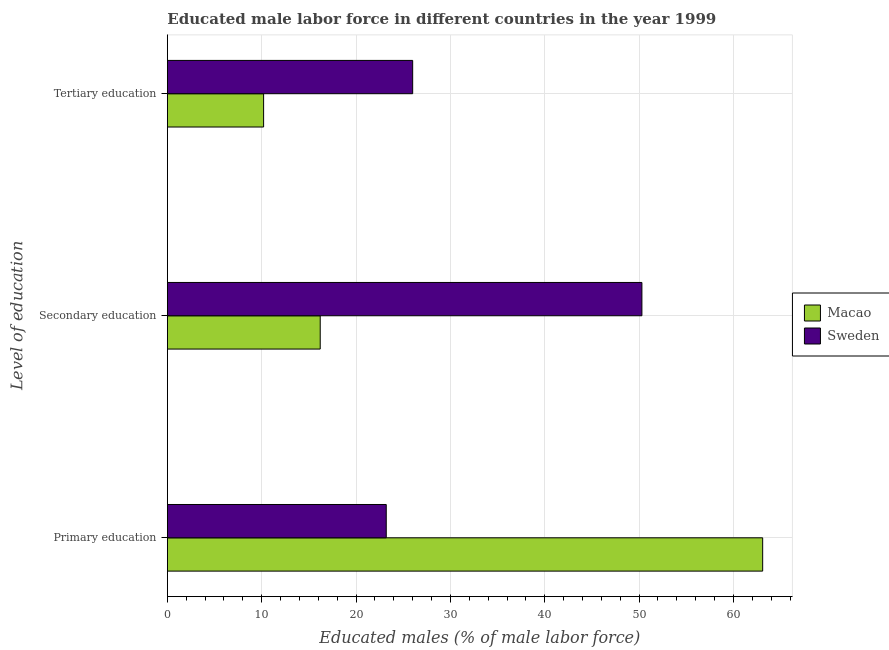How many different coloured bars are there?
Your answer should be compact. 2. Are the number of bars per tick equal to the number of legend labels?
Make the answer very short. Yes. How many bars are there on the 3rd tick from the top?
Your response must be concise. 2. What is the label of the 2nd group of bars from the top?
Ensure brevity in your answer.  Secondary education. What is the percentage of male labor force who received secondary education in Macao?
Your answer should be compact. 16.2. Across all countries, what is the maximum percentage of male labor force who received primary education?
Keep it short and to the point. 63.1. Across all countries, what is the minimum percentage of male labor force who received secondary education?
Provide a succinct answer. 16.2. In which country was the percentage of male labor force who received primary education minimum?
Offer a very short reply. Sweden. What is the total percentage of male labor force who received primary education in the graph?
Provide a short and direct response. 86.3. What is the difference between the percentage of male labor force who received secondary education in Sweden and that in Macao?
Offer a terse response. 34.1. What is the difference between the percentage of male labor force who received secondary education in Sweden and the percentage of male labor force who received tertiary education in Macao?
Offer a very short reply. 40.1. What is the average percentage of male labor force who received secondary education per country?
Keep it short and to the point. 33.25. What is the difference between the percentage of male labor force who received primary education and percentage of male labor force who received secondary education in Sweden?
Your answer should be very brief. -27.1. What is the ratio of the percentage of male labor force who received tertiary education in Macao to that in Sweden?
Your response must be concise. 0.39. Is the percentage of male labor force who received secondary education in Macao less than that in Sweden?
Make the answer very short. Yes. What is the difference between the highest and the second highest percentage of male labor force who received tertiary education?
Provide a short and direct response. 15.8. What is the difference between the highest and the lowest percentage of male labor force who received secondary education?
Your response must be concise. 34.1. In how many countries, is the percentage of male labor force who received tertiary education greater than the average percentage of male labor force who received tertiary education taken over all countries?
Your answer should be compact. 1. Is the sum of the percentage of male labor force who received tertiary education in Macao and Sweden greater than the maximum percentage of male labor force who received secondary education across all countries?
Keep it short and to the point. No. What does the 2nd bar from the top in Tertiary education represents?
Provide a succinct answer. Macao. How many bars are there?
Give a very brief answer. 6. Does the graph contain any zero values?
Provide a succinct answer. No. Where does the legend appear in the graph?
Offer a very short reply. Center right. What is the title of the graph?
Give a very brief answer. Educated male labor force in different countries in the year 1999. Does "Norway" appear as one of the legend labels in the graph?
Your answer should be compact. No. What is the label or title of the X-axis?
Provide a succinct answer. Educated males (% of male labor force). What is the label or title of the Y-axis?
Make the answer very short. Level of education. What is the Educated males (% of male labor force) of Macao in Primary education?
Your answer should be compact. 63.1. What is the Educated males (% of male labor force) of Sweden in Primary education?
Provide a short and direct response. 23.2. What is the Educated males (% of male labor force) of Macao in Secondary education?
Keep it short and to the point. 16.2. What is the Educated males (% of male labor force) in Sweden in Secondary education?
Your response must be concise. 50.3. What is the Educated males (% of male labor force) in Macao in Tertiary education?
Your answer should be very brief. 10.2. Across all Level of education, what is the maximum Educated males (% of male labor force) in Macao?
Provide a short and direct response. 63.1. Across all Level of education, what is the maximum Educated males (% of male labor force) in Sweden?
Make the answer very short. 50.3. Across all Level of education, what is the minimum Educated males (% of male labor force) in Macao?
Your response must be concise. 10.2. Across all Level of education, what is the minimum Educated males (% of male labor force) of Sweden?
Provide a short and direct response. 23.2. What is the total Educated males (% of male labor force) in Macao in the graph?
Offer a very short reply. 89.5. What is the total Educated males (% of male labor force) in Sweden in the graph?
Offer a terse response. 99.5. What is the difference between the Educated males (% of male labor force) of Macao in Primary education and that in Secondary education?
Provide a short and direct response. 46.9. What is the difference between the Educated males (% of male labor force) of Sweden in Primary education and that in Secondary education?
Ensure brevity in your answer.  -27.1. What is the difference between the Educated males (% of male labor force) in Macao in Primary education and that in Tertiary education?
Keep it short and to the point. 52.9. What is the difference between the Educated males (% of male labor force) of Sweden in Secondary education and that in Tertiary education?
Provide a succinct answer. 24.3. What is the difference between the Educated males (% of male labor force) in Macao in Primary education and the Educated males (% of male labor force) in Sweden in Tertiary education?
Ensure brevity in your answer.  37.1. What is the average Educated males (% of male labor force) in Macao per Level of education?
Ensure brevity in your answer.  29.83. What is the average Educated males (% of male labor force) of Sweden per Level of education?
Ensure brevity in your answer.  33.17. What is the difference between the Educated males (% of male labor force) of Macao and Educated males (% of male labor force) of Sweden in Primary education?
Your response must be concise. 39.9. What is the difference between the Educated males (% of male labor force) in Macao and Educated males (% of male labor force) in Sweden in Secondary education?
Ensure brevity in your answer.  -34.1. What is the difference between the Educated males (% of male labor force) in Macao and Educated males (% of male labor force) in Sweden in Tertiary education?
Provide a short and direct response. -15.8. What is the ratio of the Educated males (% of male labor force) of Macao in Primary education to that in Secondary education?
Offer a very short reply. 3.9. What is the ratio of the Educated males (% of male labor force) in Sweden in Primary education to that in Secondary education?
Ensure brevity in your answer.  0.46. What is the ratio of the Educated males (% of male labor force) in Macao in Primary education to that in Tertiary education?
Offer a very short reply. 6.19. What is the ratio of the Educated males (% of male labor force) of Sweden in Primary education to that in Tertiary education?
Offer a very short reply. 0.89. What is the ratio of the Educated males (% of male labor force) in Macao in Secondary education to that in Tertiary education?
Your answer should be compact. 1.59. What is the ratio of the Educated males (% of male labor force) in Sweden in Secondary education to that in Tertiary education?
Keep it short and to the point. 1.93. What is the difference between the highest and the second highest Educated males (% of male labor force) in Macao?
Offer a very short reply. 46.9. What is the difference between the highest and the second highest Educated males (% of male labor force) of Sweden?
Your answer should be very brief. 24.3. What is the difference between the highest and the lowest Educated males (% of male labor force) of Macao?
Offer a very short reply. 52.9. What is the difference between the highest and the lowest Educated males (% of male labor force) of Sweden?
Make the answer very short. 27.1. 